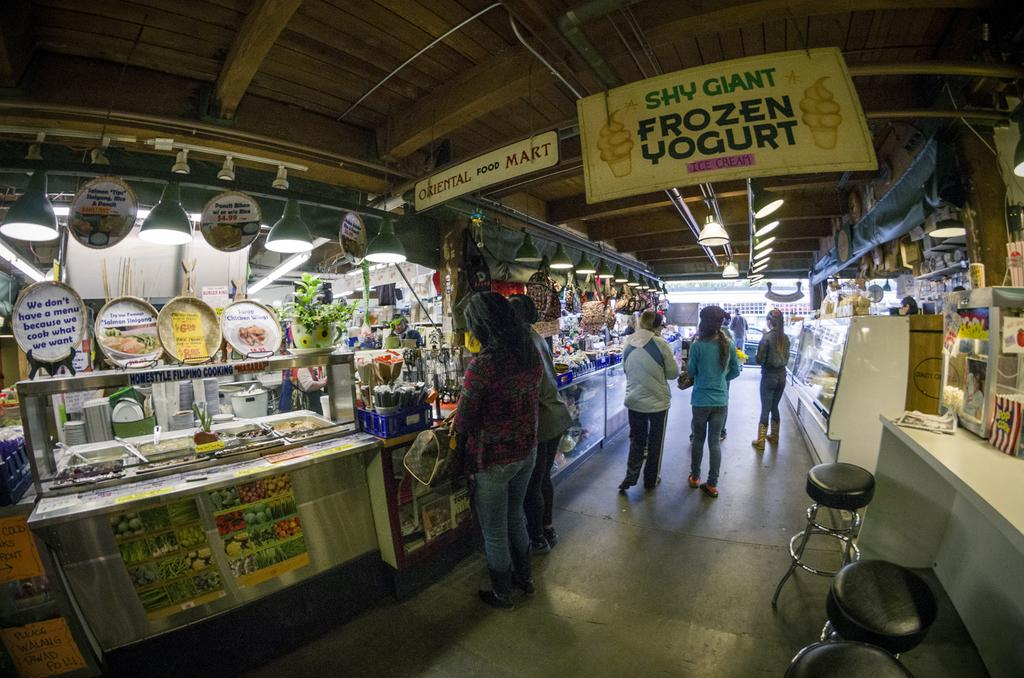Provide a one-sentence caption for the provided image. A food court with a banner advertising Shy Giant frozen yogurt. 